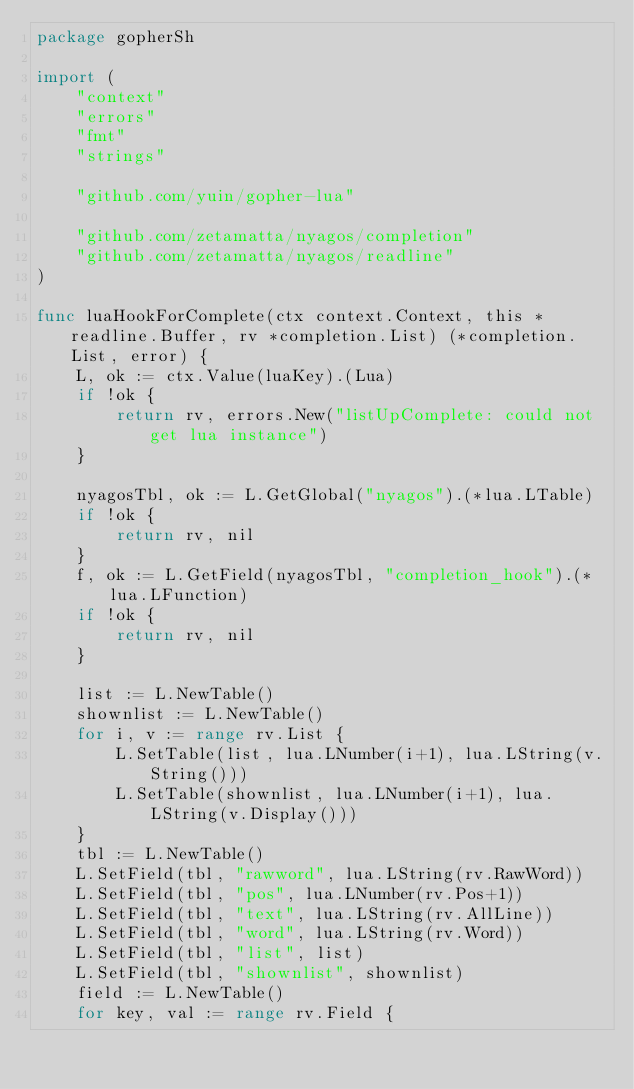<code> <loc_0><loc_0><loc_500><loc_500><_Go_>package gopherSh

import (
	"context"
	"errors"
	"fmt"
	"strings"

	"github.com/yuin/gopher-lua"

	"github.com/zetamatta/nyagos/completion"
	"github.com/zetamatta/nyagos/readline"
)

func luaHookForComplete(ctx context.Context, this *readline.Buffer, rv *completion.List) (*completion.List, error) {
	L, ok := ctx.Value(luaKey).(Lua)
	if !ok {
		return rv, errors.New("listUpComplete: could not get lua instance")
	}

	nyagosTbl, ok := L.GetGlobal("nyagos").(*lua.LTable)
	if !ok {
		return rv, nil
	}
	f, ok := L.GetField(nyagosTbl, "completion_hook").(*lua.LFunction)
	if !ok {
		return rv, nil
	}

	list := L.NewTable()
	shownlist := L.NewTable()
	for i, v := range rv.List {
		L.SetTable(list, lua.LNumber(i+1), lua.LString(v.String()))
		L.SetTable(shownlist, lua.LNumber(i+1), lua.LString(v.Display()))
	}
	tbl := L.NewTable()
	L.SetField(tbl, "rawword", lua.LString(rv.RawWord))
	L.SetField(tbl, "pos", lua.LNumber(rv.Pos+1))
	L.SetField(tbl, "text", lua.LString(rv.AllLine))
	L.SetField(tbl, "word", lua.LString(rv.Word))
	L.SetField(tbl, "list", list)
	L.SetField(tbl, "shownlist", shownlist)
	field := L.NewTable()
	for key, val := range rv.Field {</code> 